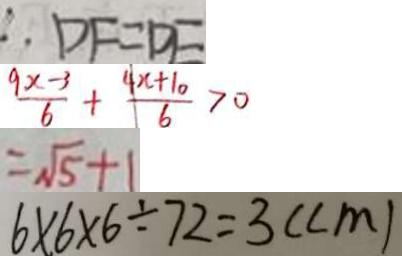Convert formula to latex. <formula><loc_0><loc_0><loc_500><loc_500>\therefore D F = D E 
 \frac { 9 x - 3 } { 6 } + \frac { 4 x + 1 0 } { 6 } > 0 
 = \sqrt { 5 } + 1 
 6 \times 6 \times 6 \div 7 2 = 3 ( c m )</formula> 